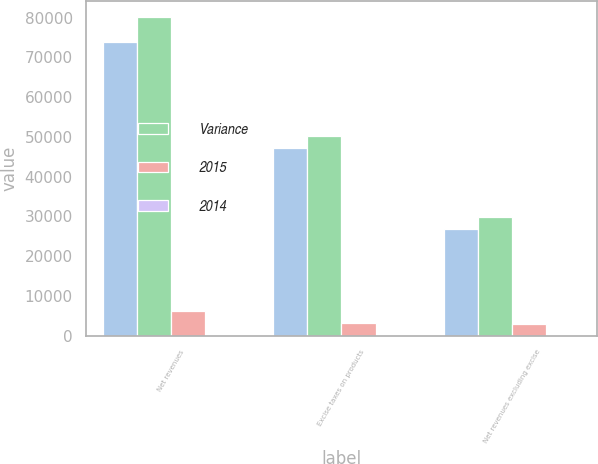<chart> <loc_0><loc_0><loc_500><loc_500><stacked_bar_chart><ecel><fcel>Net revenues<fcel>Excise taxes on products<fcel>Net revenues excluding excise<nl><fcel>nan<fcel>73908<fcel>47114<fcel>26794<nl><fcel>Variance<fcel>80106<fcel>50339<fcel>29767<nl><fcel>2015<fcel>6198<fcel>3225<fcel>2973<nl><fcel>2014<fcel>7.7<fcel>6.4<fcel>10<nl></chart> 